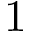Convert formula to latex. <formula><loc_0><loc_0><loc_500><loc_500>1</formula> 